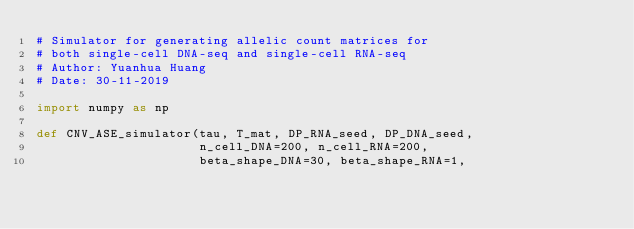Convert code to text. <code><loc_0><loc_0><loc_500><loc_500><_Python_># Simulator for generating allelic count matrices for
# both single-cell DNA-seq and single-cell RNA-seq
# Author: Yuanhua Huang
# Date: 30-11-2019

import numpy as np

def CNV_ASE_simulator(tau, T_mat, DP_RNA_seed, DP_DNA_seed,
                      n_cell_DNA=200, n_cell_RNA=200, 
                      beta_shape_DNA=30, beta_shape_RNA=1,</code> 